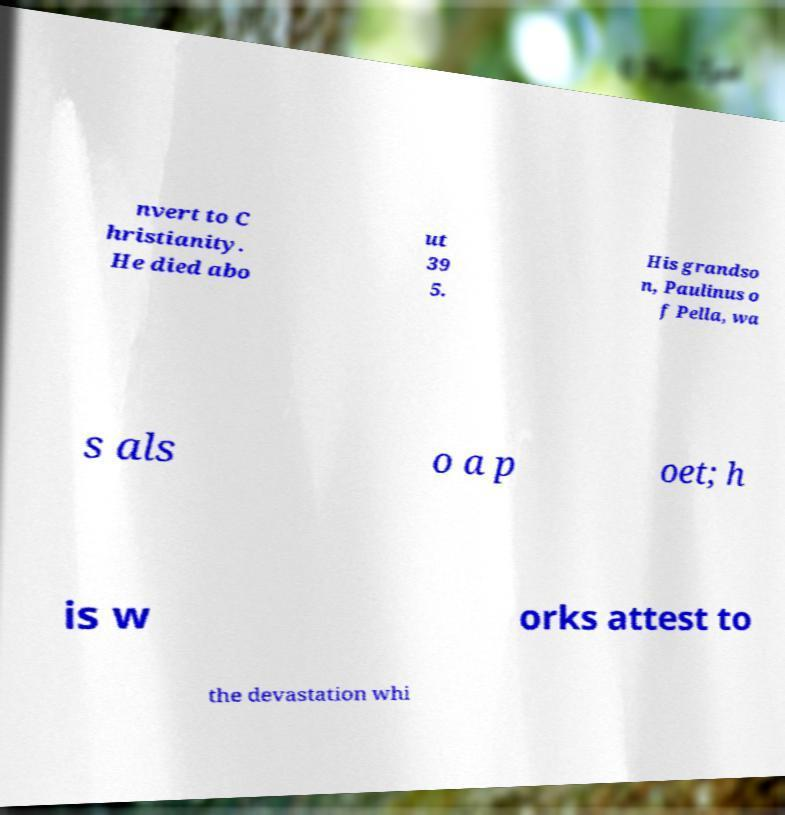What messages or text are displayed in this image? I need them in a readable, typed format. nvert to C hristianity. He died abo ut 39 5. His grandso n, Paulinus o f Pella, wa s als o a p oet; h is w orks attest to the devastation whi 